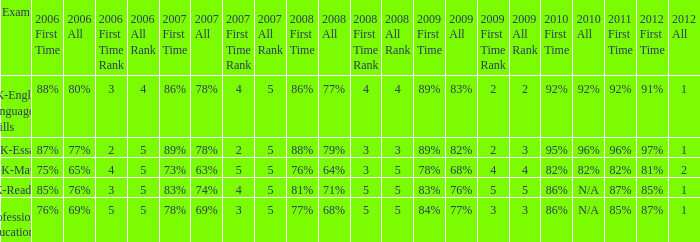What is the percentage for first time in 2012 when it was 82% for all in 2009? 97%. 